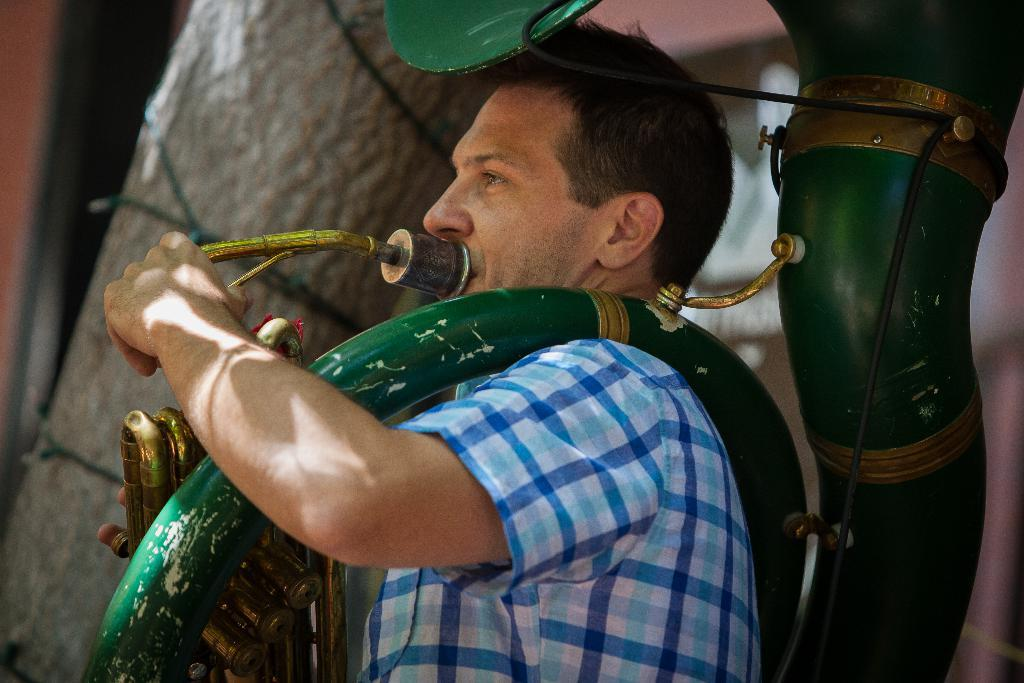What is the main subject of the image? The main subject of the image is a man. What is the man doing in the image? The man is playing a musical instrument in the image. What type of toy is the man playing with in the image? There is no toy present in the image; the man is playing a musical instrument. What color is the soap the man is holding in the image? There is no soap present in the image; the man is playing a musical instrument. 